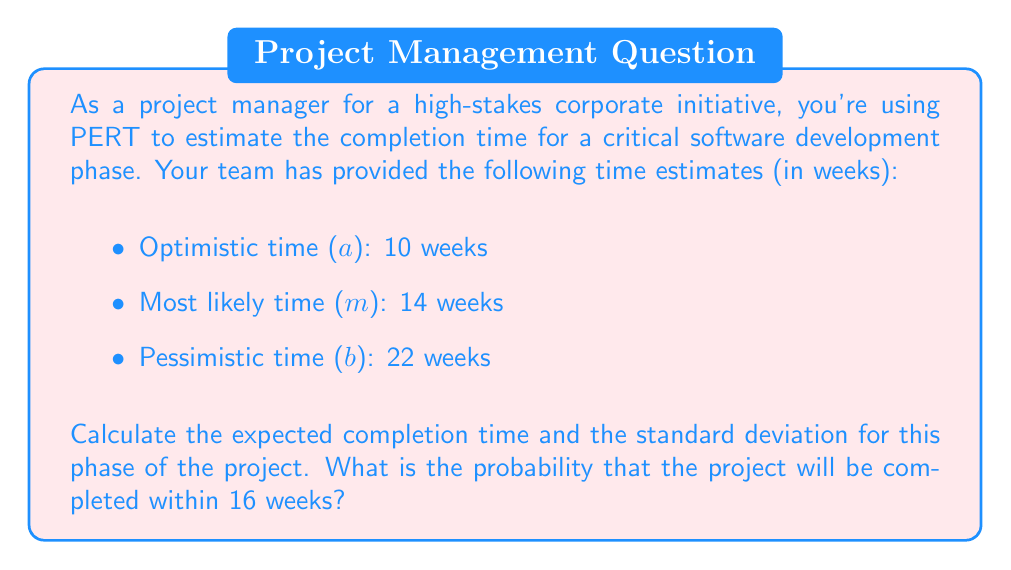Give your solution to this math problem. To solve this problem, we'll use the PERT formulas and the standard normal distribution.

1. Calculate the expected time (TE):
   $$TE = \frac{a + 4m + b}{6}$$
   $$TE = \frac{10 + 4(14) + 22}{6} = \frac{10 + 56 + 22}{6} = \frac{88}{6} = 14.67 \text{ weeks}$$

2. Calculate the standard deviation (σ):
   $$\sigma = \frac{b - a}{6}$$
   $$\sigma = \frac{22 - 10}{6} = \frac{12}{6} = 2 \text{ weeks}$$

3. Calculate the z-score for 16 weeks:
   $$z = \frac{x - \mu}{\sigma}$$
   Where x is the target time, μ is the expected time (TE), and σ is the standard deviation.
   $$z = \frac{16 - 14.67}{2} = 0.665$$

4. Use a standard normal distribution table or calculator to find the probability:
   The probability of completing within 16 weeks is the area under the normal curve to the left of z = 0.665.
   This probability is approximately 0.7470 or 74.70%.
Answer: Expected completion time: 14.67 weeks
Standard deviation: 2 weeks
Probability of completion within 16 weeks: 74.70% 